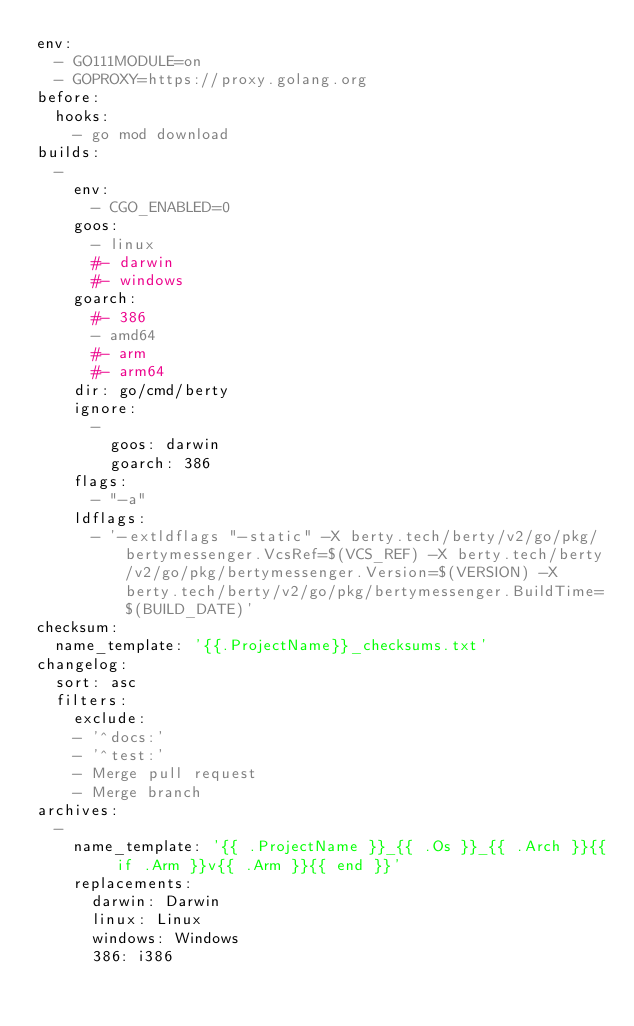<code> <loc_0><loc_0><loc_500><loc_500><_YAML_>env:
  - GO111MODULE=on
  - GOPROXY=https://proxy.golang.org
before:
  hooks:
    - go mod download
builds:
  -
    env:
      - CGO_ENABLED=0
    goos:
      - linux
      #- darwin
      #- windows
    goarch:
      #- 386
      - amd64
      #- arm
      #- arm64
    dir: go/cmd/berty
    ignore:
      -
        goos: darwin
        goarch: 386
    flags:
      - "-a"
    ldflags:
      - '-extldflags "-static" -X berty.tech/berty/v2/go/pkg/bertymessenger.VcsRef=$(VCS_REF) -X berty.tech/berty/v2/go/pkg/bertymessenger.Version=$(VERSION) -X berty.tech/berty/v2/go/pkg/bertymessenger.BuildTime=$(BUILD_DATE)'
checksum:
  name_template: '{{.ProjectName}}_checksums.txt'
changelog:
  sort: asc
  filters:
    exclude:
    - '^docs:'
    - '^test:'
    - Merge pull request
    - Merge branch
archives:
  -
    name_template: '{{ .ProjectName }}_{{ .Os }}_{{ .Arch }}{{ if .Arm }}v{{ .Arm }}{{ end }}'
    replacements:
      darwin: Darwin
      linux: Linux
      windows: Windows
      386: i386</code> 